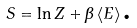<formula> <loc_0><loc_0><loc_500><loc_500>S = \ln Z + \beta \left \langle E \right \rangle \text {.}</formula> 